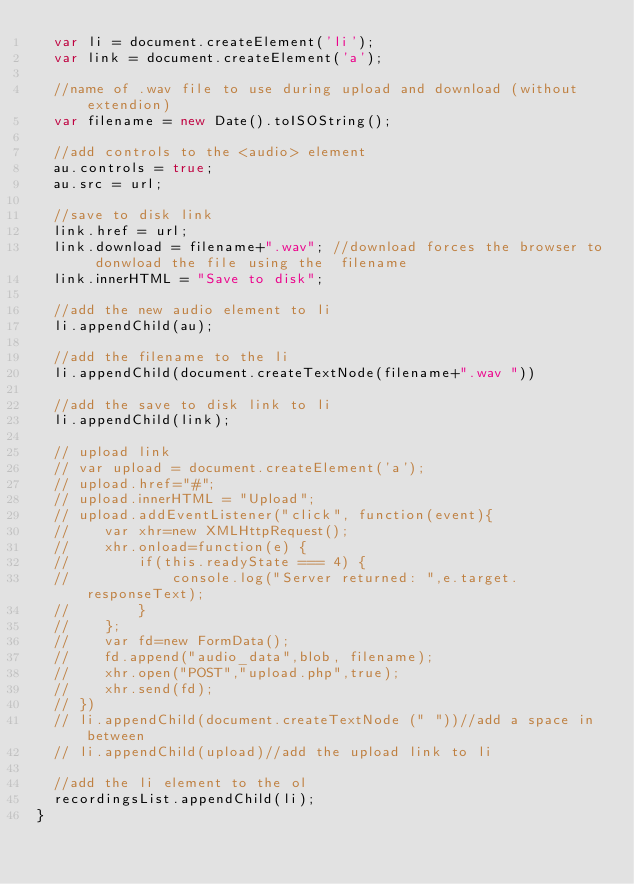Convert code to text. <code><loc_0><loc_0><loc_500><loc_500><_JavaScript_>	var li = document.createElement('li');
	var link = document.createElement('a');

	//name of .wav file to use during upload and download (without extendion)
	var filename = new Date().toISOString();

	//add controls to the <audio> element
	au.controls = true;
	au.src = url;

	//save to disk link
	link.href = url;
	link.download = filename+".wav"; //download forces the browser to donwload the file using the  filename
	link.innerHTML = "Save to disk";

	//add the new audio element to li
	li.appendChild(au);
	
	//add the filename to the li
	li.appendChild(document.createTextNode(filename+".wav "))

	//add the save to disk link to li
	li.appendChild(link);
	
	// upload link
	// var upload = document.createElement('a');
	// upload.href="#";
	// upload.innerHTML = "Upload";
	// upload.addEventListener("click", function(event){
	// 	  var xhr=new XMLHttpRequest();
	// 	  xhr.onload=function(e) {
	// 	      if(this.readyState === 4) {
	// 	          console.log("Server returned: ",e.target.responseText);
	// 	      }
	// 	  };
	// 	  var fd=new FormData();
	// 	  fd.append("audio_data",blob, filename);
	// 	  xhr.open("POST","upload.php",true);
	// 	  xhr.send(fd);
	// })
	// li.appendChild(document.createTextNode (" "))//add a space in between
	// li.appendChild(upload)//add the upload link to li

	//add the li element to the ol
	recordingsList.appendChild(li);
}</code> 